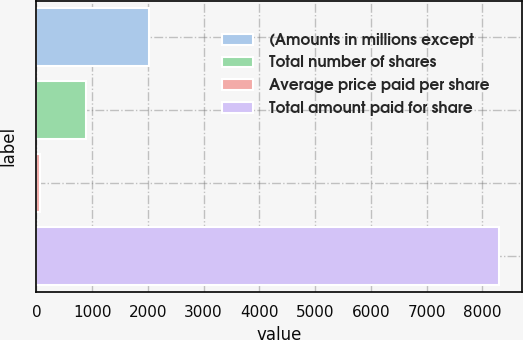<chart> <loc_0><loc_0><loc_500><loc_500><bar_chart><fcel>(Amounts in millions except<fcel>Total number of shares<fcel>Average price paid per share<fcel>Total amount paid for share<nl><fcel>2017<fcel>892.06<fcel>69.18<fcel>8298<nl></chart> 